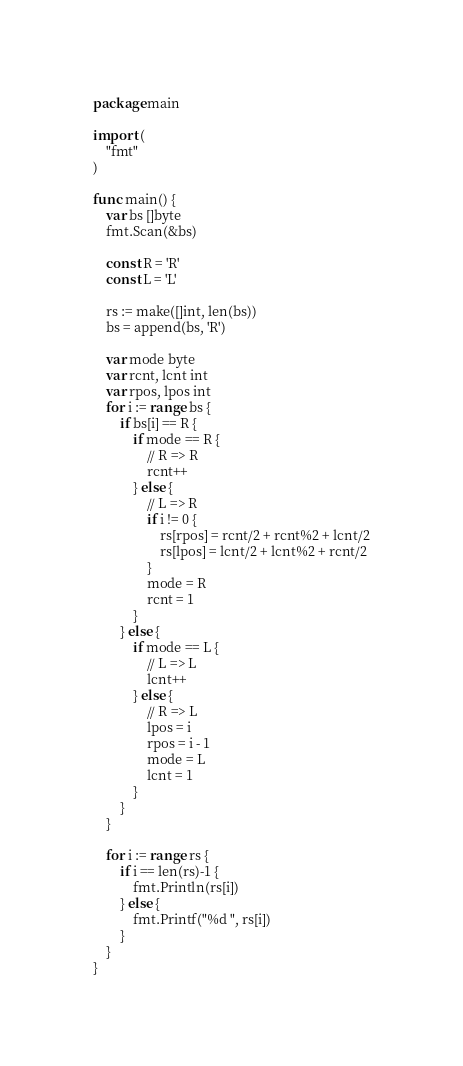<code> <loc_0><loc_0><loc_500><loc_500><_Go_>package main

import (
    "fmt"
)

func main() {
    var bs []byte
    fmt.Scan(&bs)

    const R = 'R'
    const L = 'L'

    rs := make([]int, len(bs))
    bs = append(bs, 'R')

    var mode byte
    var rcnt, lcnt int
    var rpos, lpos int
    for i := range bs {
        if bs[i] == R {
            if mode == R {
                // R => R
                rcnt++
            } else {
                // L => R
                if i != 0 {
                    rs[rpos] = rcnt/2 + rcnt%2 + lcnt/2
                    rs[lpos] = lcnt/2 + lcnt%2 + rcnt/2
                }
                mode = R
                rcnt = 1
            }
        } else {
            if mode == L {
                // L => L
                lcnt++
            } else {
                // R => L
                lpos = i
                rpos = i - 1
                mode = L
                lcnt = 1
            }
        }
    }

    for i := range rs {
        if i == len(rs)-1 {
            fmt.Println(rs[i])
        } else {
            fmt.Printf("%d ", rs[i])
        }
    }
}
</code> 